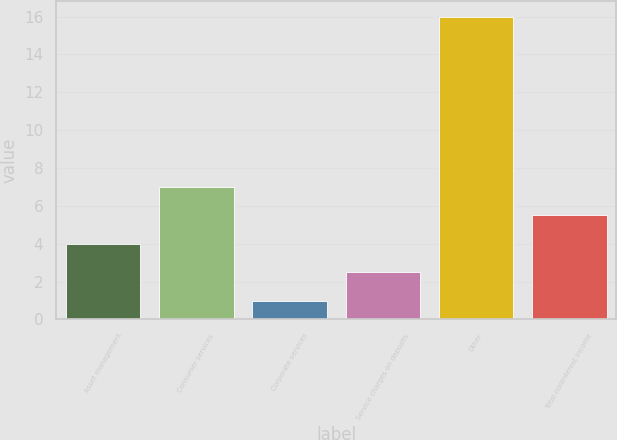Convert chart. <chart><loc_0><loc_0><loc_500><loc_500><bar_chart><fcel>Asset management<fcel>Consumer services<fcel>Corporate services<fcel>Service charges on deposits<fcel>Other<fcel>Total noninterest income<nl><fcel>4<fcel>7<fcel>1<fcel>2.5<fcel>16<fcel>5.5<nl></chart> 